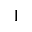Convert formula to latex. <formula><loc_0><loc_0><loc_500><loc_500>1</formula> 